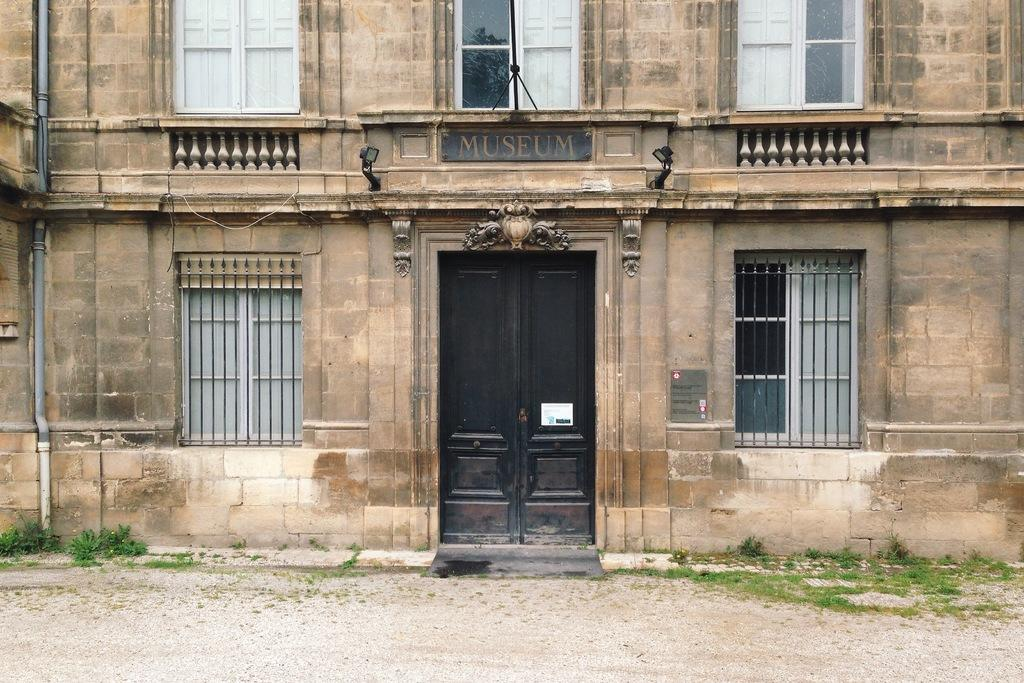What type of opening can be seen in the image? There is a door in the image. Where are additional openings located in the image? There are windows at the bottom and top of the image. What is the tendency of the dolls to move around in the image? There are no dolls present in the image, so it is not possible to determine their tendency to move around. 